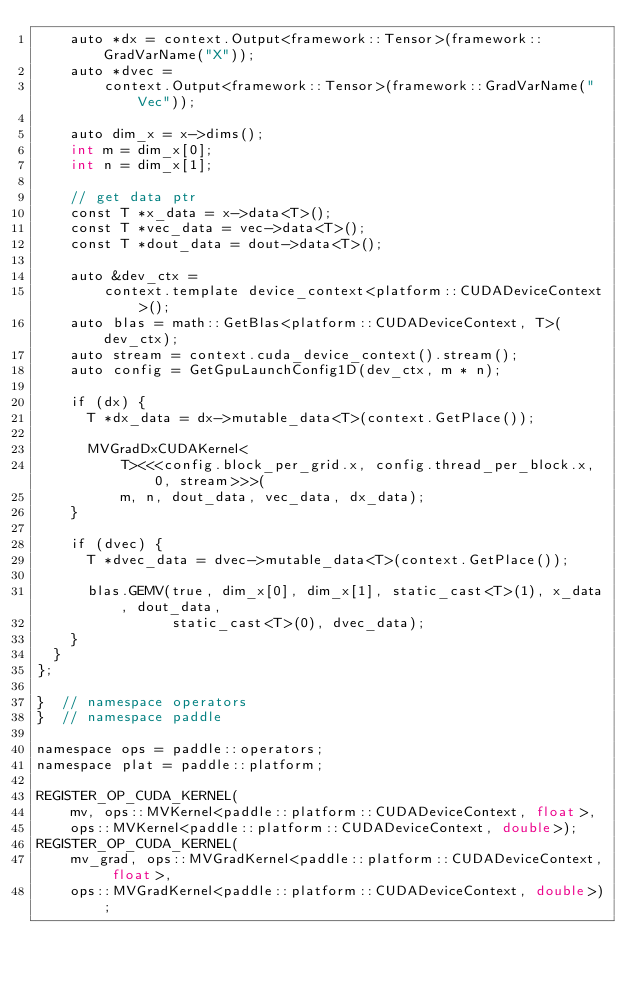Convert code to text. <code><loc_0><loc_0><loc_500><loc_500><_Cuda_>    auto *dx = context.Output<framework::Tensor>(framework::GradVarName("X"));
    auto *dvec =
        context.Output<framework::Tensor>(framework::GradVarName("Vec"));

    auto dim_x = x->dims();
    int m = dim_x[0];
    int n = dim_x[1];

    // get data ptr
    const T *x_data = x->data<T>();
    const T *vec_data = vec->data<T>();
    const T *dout_data = dout->data<T>();

    auto &dev_ctx =
        context.template device_context<platform::CUDADeviceContext>();
    auto blas = math::GetBlas<platform::CUDADeviceContext, T>(dev_ctx);
    auto stream = context.cuda_device_context().stream();
    auto config = GetGpuLaunchConfig1D(dev_ctx, m * n);

    if (dx) {
      T *dx_data = dx->mutable_data<T>(context.GetPlace());

      MVGradDxCUDAKernel<
          T><<<config.block_per_grid.x, config.thread_per_block.x, 0, stream>>>(
          m, n, dout_data, vec_data, dx_data);
    }

    if (dvec) {
      T *dvec_data = dvec->mutable_data<T>(context.GetPlace());

      blas.GEMV(true, dim_x[0], dim_x[1], static_cast<T>(1), x_data, dout_data,
                static_cast<T>(0), dvec_data);
    }
  }
};

}  // namespace operators
}  // namespace paddle

namespace ops = paddle::operators;
namespace plat = paddle::platform;

REGISTER_OP_CUDA_KERNEL(
    mv, ops::MVKernel<paddle::platform::CUDADeviceContext, float>,
    ops::MVKernel<paddle::platform::CUDADeviceContext, double>);
REGISTER_OP_CUDA_KERNEL(
    mv_grad, ops::MVGradKernel<paddle::platform::CUDADeviceContext, float>,
    ops::MVGradKernel<paddle::platform::CUDADeviceContext, double>);
</code> 